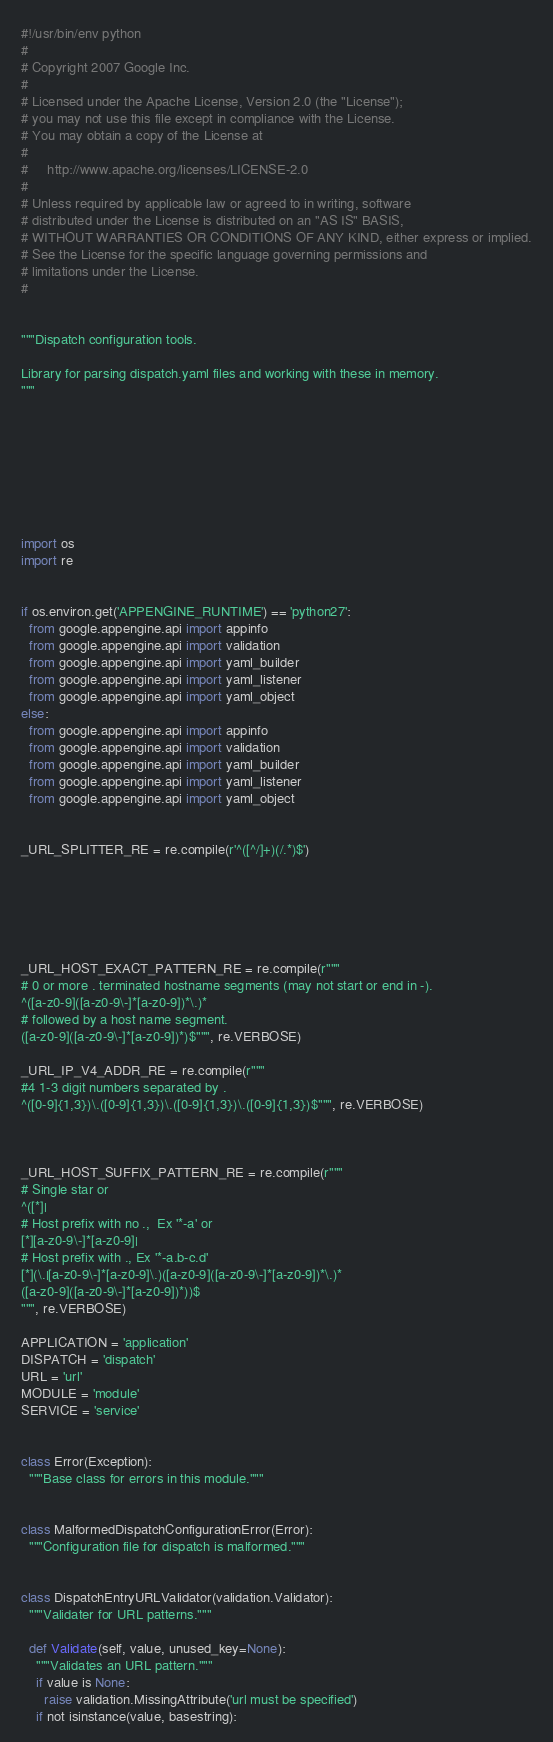Convert code to text. <code><loc_0><loc_0><loc_500><loc_500><_Python_>#!/usr/bin/env python
#
# Copyright 2007 Google Inc.
#
# Licensed under the Apache License, Version 2.0 (the "License");
# you may not use this file except in compliance with the License.
# You may obtain a copy of the License at
#
#     http://www.apache.org/licenses/LICENSE-2.0
#
# Unless required by applicable law or agreed to in writing, software
# distributed under the License is distributed on an "AS IS" BASIS,
# WITHOUT WARRANTIES OR CONDITIONS OF ANY KIND, either express or implied.
# See the License for the specific language governing permissions and
# limitations under the License.
#


"""Dispatch configuration tools.

Library for parsing dispatch.yaml files and working with these in memory.
"""








import os
import re


if os.environ.get('APPENGINE_RUNTIME') == 'python27':
  from google.appengine.api import appinfo
  from google.appengine.api import validation
  from google.appengine.api import yaml_builder
  from google.appengine.api import yaml_listener
  from google.appengine.api import yaml_object
else:
  from google.appengine.api import appinfo
  from google.appengine.api import validation
  from google.appengine.api import yaml_builder
  from google.appengine.api import yaml_listener
  from google.appengine.api import yaml_object


_URL_SPLITTER_RE = re.compile(r'^([^/]+)(/.*)$')






_URL_HOST_EXACT_PATTERN_RE = re.compile(r"""
# 0 or more . terminated hostname segments (may not start or end in -).
^([a-z0-9]([a-z0-9\-]*[a-z0-9])*\.)*
# followed by a host name segment.
([a-z0-9]([a-z0-9\-]*[a-z0-9])*)$""", re.VERBOSE)

_URL_IP_V4_ADDR_RE = re.compile(r"""
#4 1-3 digit numbers separated by .
^([0-9]{1,3})\.([0-9]{1,3})\.([0-9]{1,3})\.([0-9]{1,3})$""", re.VERBOSE)



_URL_HOST_SUFFIX_PATTERN_RE = re.compile(r"""
# Single star or
^([*]|
# Host prefix with no .,  Ex '*-a' or
[*][a-z0-9\-]*[a-z0-9]|
# Host prefix with ., Ex '*-a.b-c.d'
[*](\.|[a-z0-9\-]*[a-z0-9]\.)([a-z0-9]([a-z0-9\-]*[a-z0-9])*\.)*
([a-z0-9]([a-z0-9\-]*[a-z0-9])*))$
""", re.VERBOSE)

APPLICATION = 'application'
DISPATCH = 'dispatch'
URL = 'url'
MODULE = 'module'
SERVICE = 'service'


class Error(Exception):
  """Base class for errors in this module."""


class MalformedDispatchConfigurationError(Error):
  """Configuration file for dispatch is malformed."""


class DispatchEntryURLValidator(validation.Validator):
  """Validater for URL patterns."""

  def Validate(self, value, unused_key=None):
    """Validates an URL pattern."""
    if value is None:
      raise validation.MissingAttribute('url must be specified')
    if not isinstance(value, basestring):</code> 